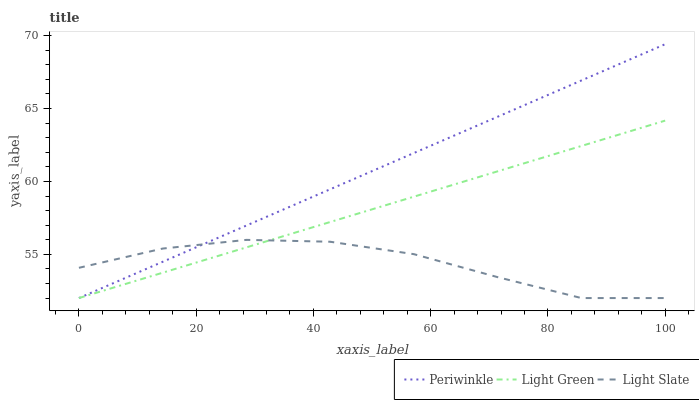Does Light Slate have the minimum area under the curve?
Answer yes or no. Yes. Does Periwinkle have the maximum area under the curve?
Answer yes or no. Yes. Does Light Green have the minimum area under the curve?
Answer yes or no. No. Does Light Green have the maximum area under the curve?
Answer yes or no. No. Is Light Green the smoothest?
Answer yes or no. Yes. Is Light Slate the roughest?
Answer yes or no. Yes. Is Periwinkle the smoothest?
Answer yes or no. No. Is Periwinkle the roughest?
Answer yes or no. No. Does Light Slate have the lowest value?
Answer yes or no. Yes. Does Periwinkle have the highest value?
Answer yes or no. Yes. Does Light Green have the highest value?
Answer yes or no. No. Does Periwinkle intersect Light Slate?
Answer yes or no. Yes. Is Periwinkle less than Light Slate?
Answer yes or no. No. Is Periwinkle greater than Light Slate?
Answer yes or no. No. 